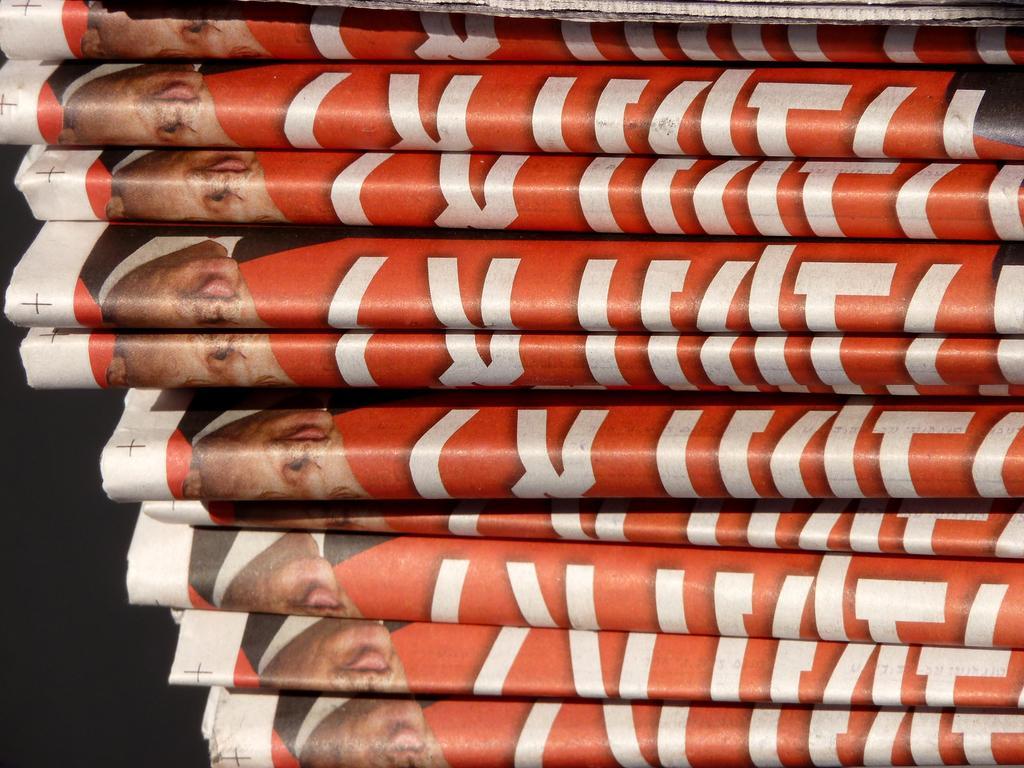Describe this image in one or two sentences. In this image, we can see the papers. On these papers, we can see some letters as well as faces of people. On the left side bottom, we can see dark view. 